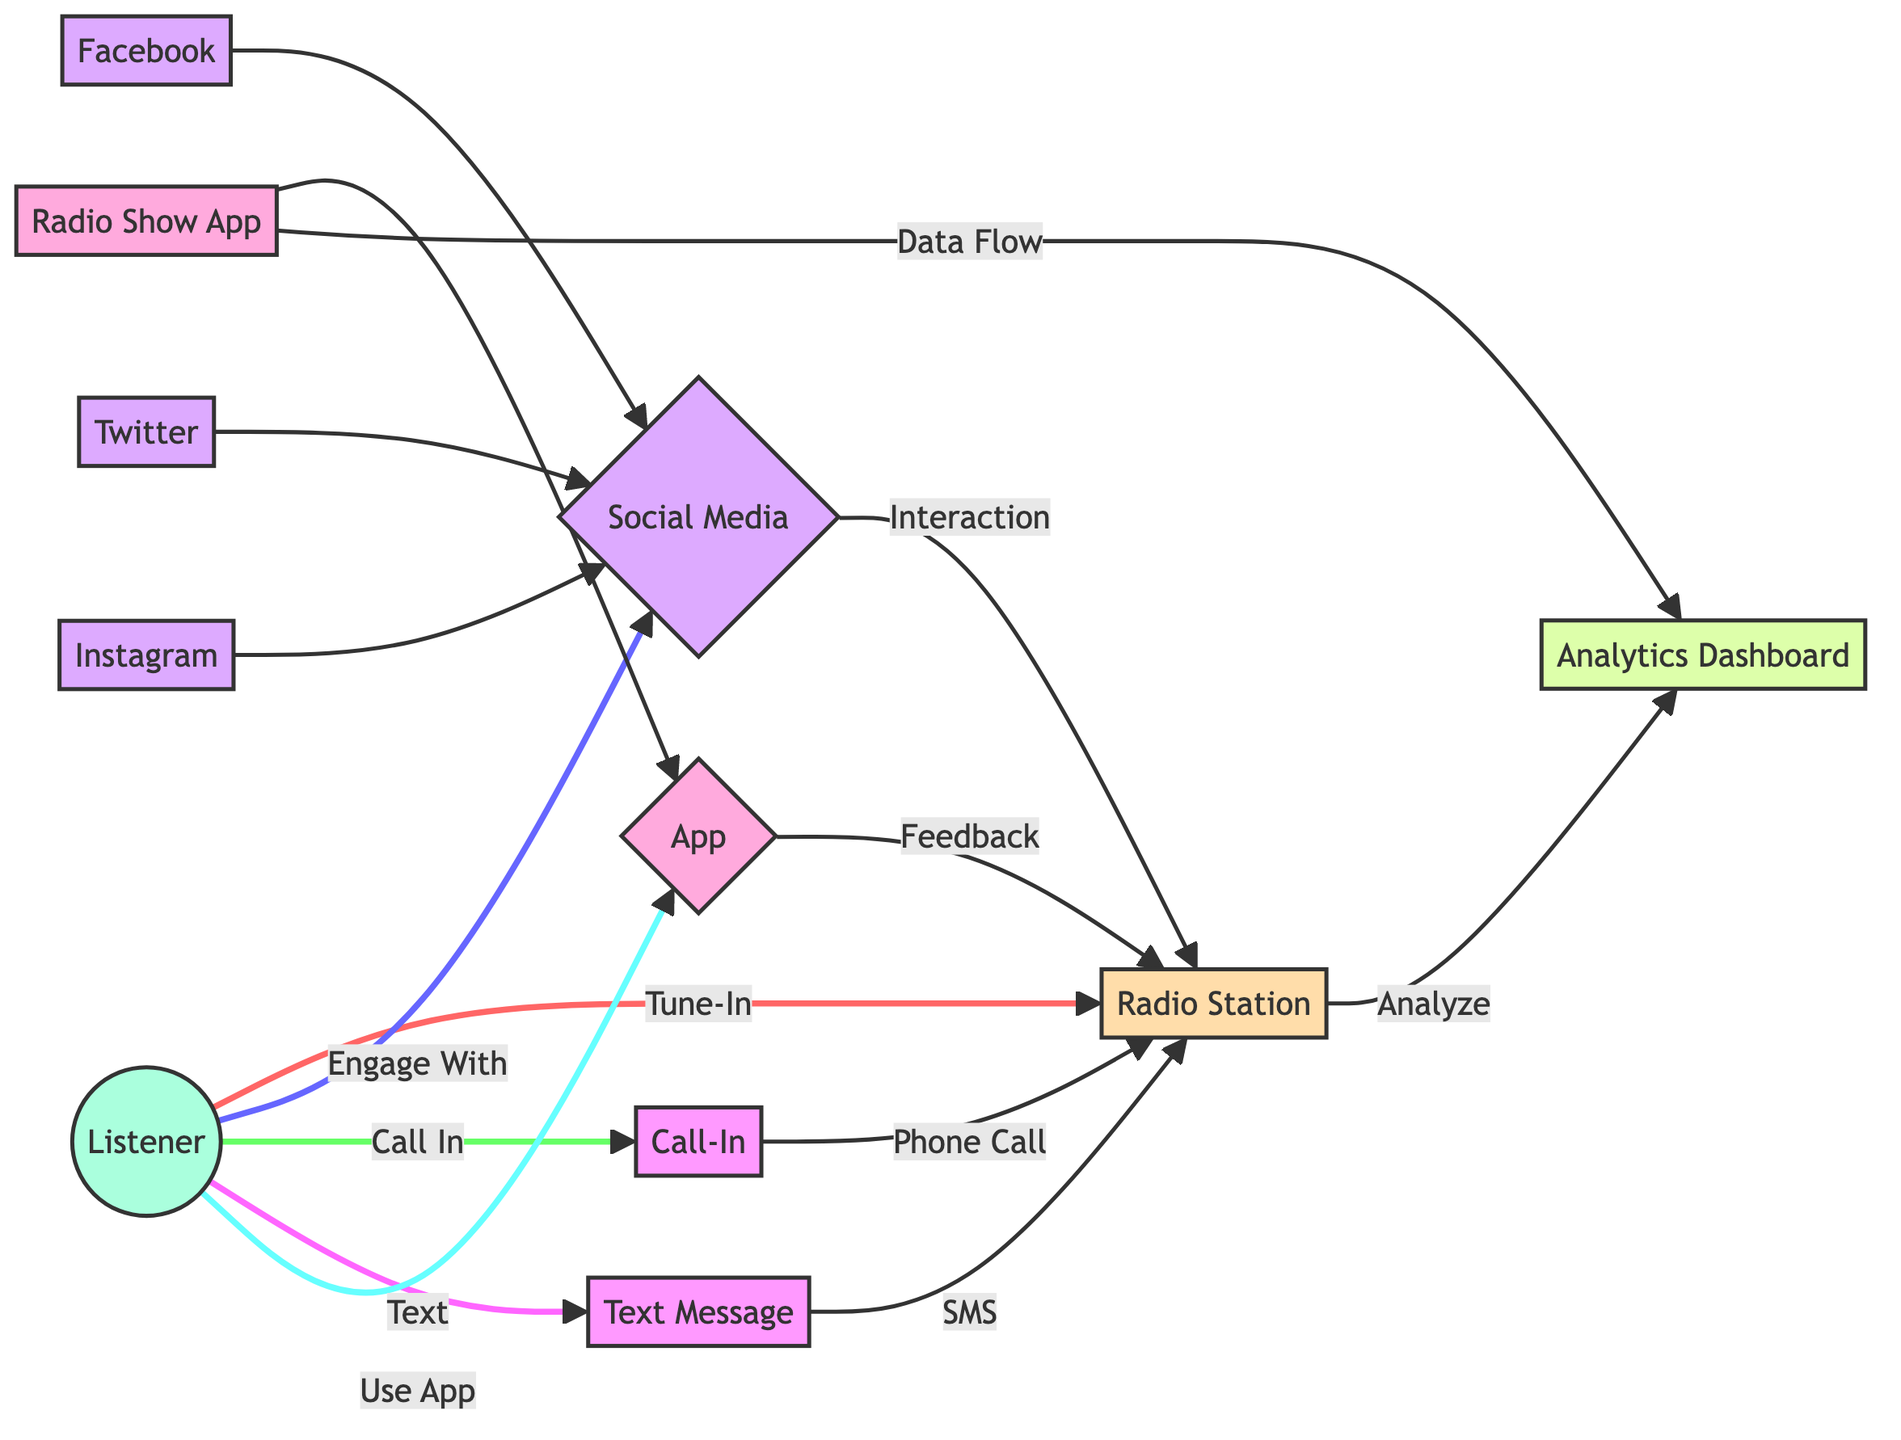What is the total number of nodes in the diagram? The diagram lists 11 unique entities which represent the nodes, including the Listener, Radio Station, various Social Media platforms, and the Analytics Dashboard.
Answer: 11 Which node is labeled as the main communication channel for listeners? The edges indicate that all listener interactions lead back to the Radio Station. This suggests the Listener node is the primary node for communication and engagement.
Answer: Radio Station What is the label of the connection from Listener to Social Media? The edge from Listener to Social Media is labeled "Engage With," indicating the nature of interaction between them.
Answer: Engage With How many social media platforms are shown in the diagram? The diagram includes three distinct social media platforms: Facebook, Twitter, and Instagram, each represented as a node connected to the Social Media node.
Answer: 3 What type of interaction does the App node have with the Radio Station node? The edge from App to Radio Station is labeled "Feedback," indicating that interactions through the App provide feedback to the Radio Station.
Answer: Feedback Which node connects to the Analytics Dashboard from Radio App? The edge connecting Radio App to Analytics Dashboard is labeled "Data Flow," indicating that data is transmitted from the Radio App to the Analytics Dashboard.
Answer: Data Flow Which channel allows listeners to call in directly? The Call In node connects directly to the Radio Station with the edge labeled "Phone Call," representing the call-in communication pathway.
Answer: Phone Call What are the three types of platforms listed under the Social Media node? The edges from the Social Media node express connections to Facebook, Twitter, and Instagram, confirming these as the three platforms associated with social media engagement.
Answer: Facebook, Twitter, Instagram How does the Listener engage with Text Messages? The edge from Listener to Text Message is labeled "Text," indicating that interaction occurs when listeners send text messages directly to the Radio Station.
Answer: Text 